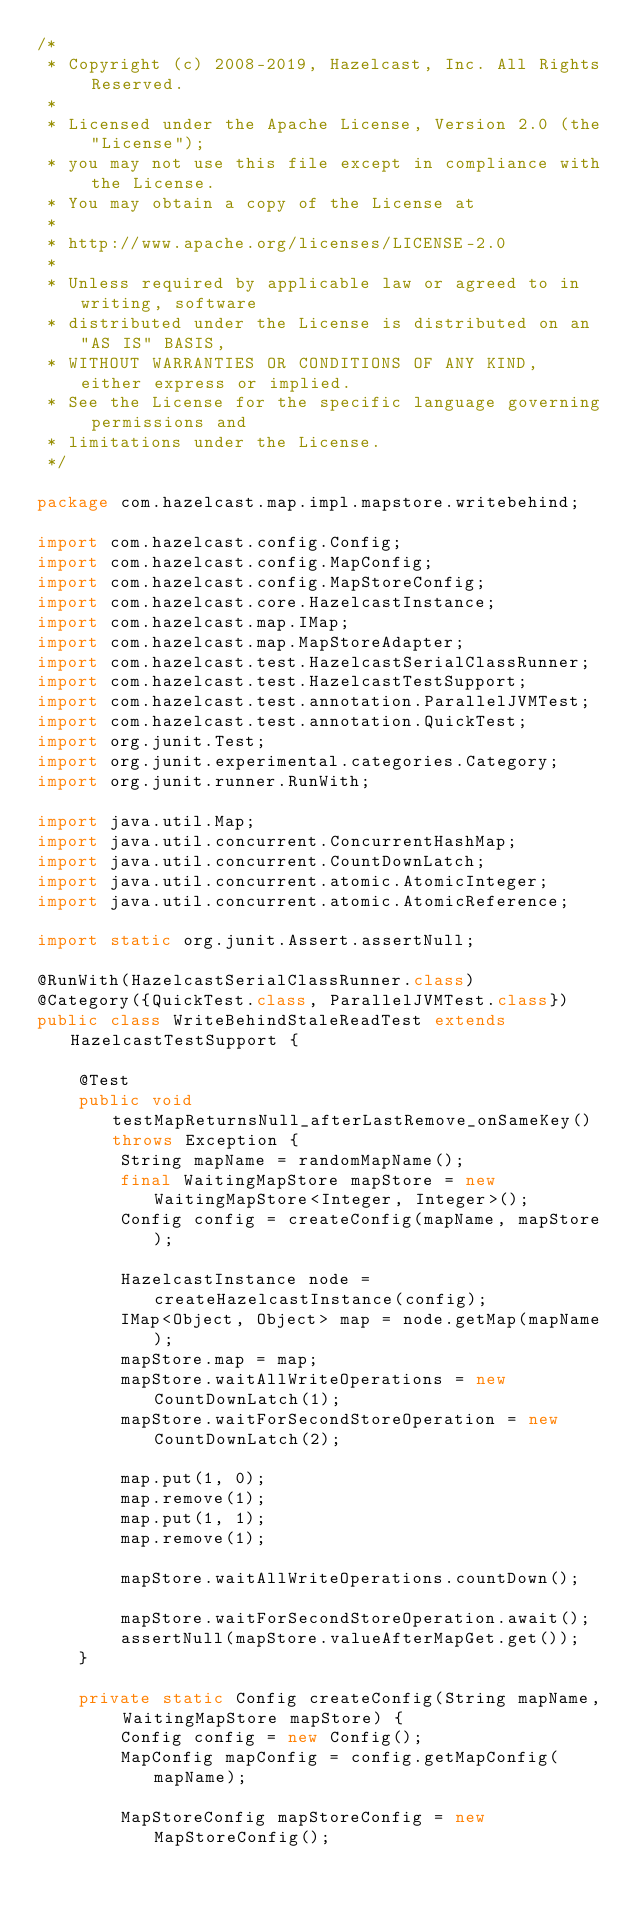Convert code to text. <code><loc_0><loc_0><loc_500><loc_500><_Java_>/*
 * Copyright (c) 2008-2019, Hazelcast, Inc. All Rights Reserved.
 *
 * Licensed under the Apache License, Version 2.0 (the "License");
 * you may not use this file except in compliance with the License.
 * You may obtain a copy of the License at
 *
 * http://www.apache.org/licenses/LICENSE-2.0
 *
 * Unless required by applicable law or agreed to in writing, software
 * distributed under the License is distributed on an "AS IS" BASIS,
 * WITHOUT WARRANTIES OR CONDITIONS OF ANY KIND, either express or implied.
 * See the License for the specific language governing permissions and
 * limitations under the License.
 */

package com.hazelcast.map.impl.mapstore.writebehind;

import com.hazelcast.config.Config;
import com.hazelcast.config.MapConfig;
import com.hazelcast.config.MapStoreConfig;
import com.hazelcast.core.HazelcastInstance;
import com.hazelcast.map.IMap;
import com.hazelcast.map.MapStoreAdapter;
import com.hazelcast.test.HazelcastSerialClassRunner;
import com.hazelcast.test.HazelcastTestSupport;
import com.hazelcast.test.annotation.ParallelJVMTest;
import com.hazelcast.test.annotation.QuickTest;
import org.junit.Test;
import org.junit.experimental.categories.Category;
import org.junit.runner.RunWith;

import java.util.Map;
import java.util.concurrent.ConcurrentHashMap;
import java.util.concurrent.CountDownLatch;
import java.util.concurrent.atomic.AtomicInteger;
import java.util.concurrent.atomic.AtomicReference;

import static org.junit.Assert.assertNull;

@RunWith(HazelcastSerialClassRunner.class)
@Category({QuickTest.class, ParallelJVMTest.class})
public class WriteBehindStaleReadTest extends HazelcastTestSupport {

    @Test
    public void testMapReturnsNull_afterLastRemove_onSameKey() throws Exception {
        String mapName = randomMapName();
        final WaitingMapStore mapStore = new WaitingMapStore<Integer, Integer>();
        Config config = createConfig(mapName, mapStore);

        HazelcastInstance node = createHazelcastInstance(config);
        IMap<Object, Object> map = node.getMap(mapName);
        mapStore.map = map;
        mapStore.waitAllWriteOperations = new CountDownLatch(1);
        mapStore.waitForSecondStoreOperation = new CountDownLatch(2);

        map.put(1, 0);
        map.remove(1);
        map.put(1, 1);
        map.remove(1);

        mapStore.waitAllWriteOperations.countDown();

        mapStore.waitForSecondStoreOperation.await();
        assertNull(mapStore.valueAfterMapGet.get());
    }

    private static Config createConfig(String mapName, WaitingMapStore mapStore) {
        Config config = new Config();
        MapConfig mapConfig = config.getMapConfig(mapName);

        MapStoreConfig mapStoreConfig = new MapStoreConfig();</code> 